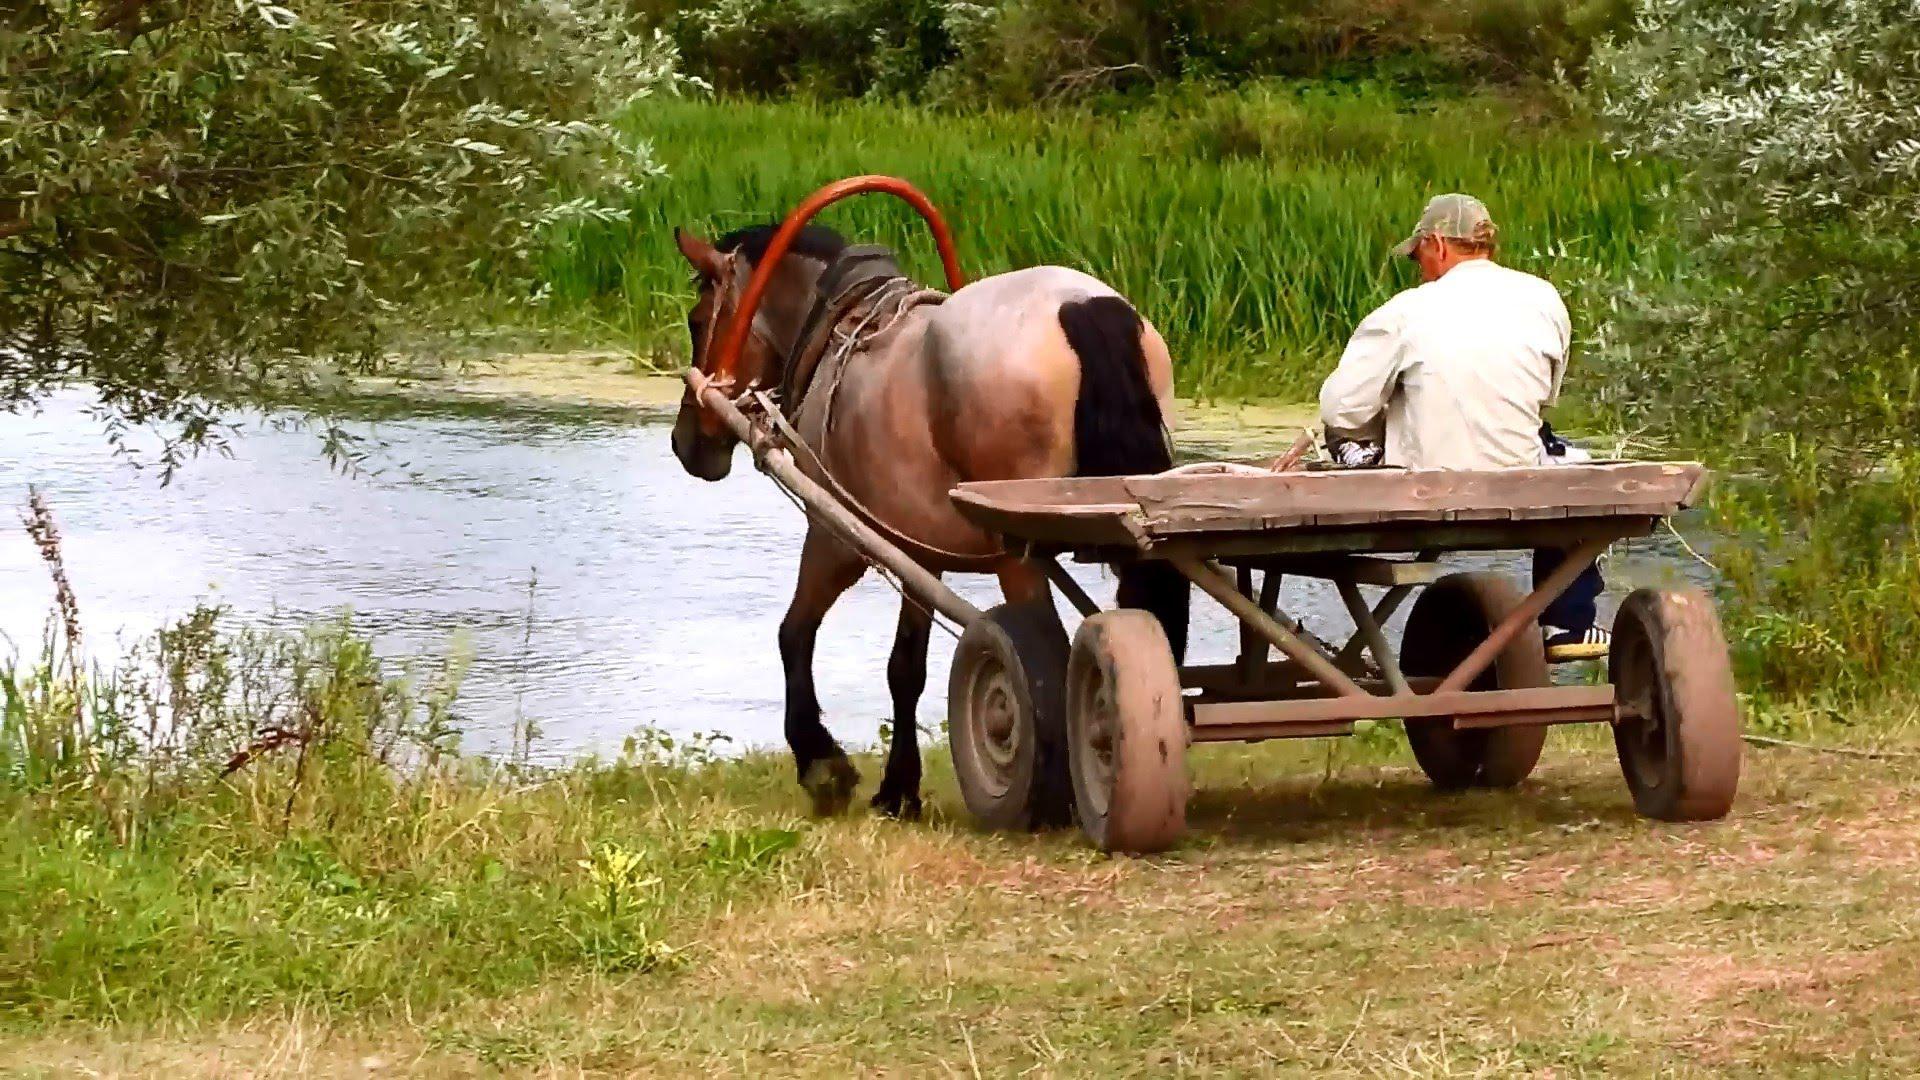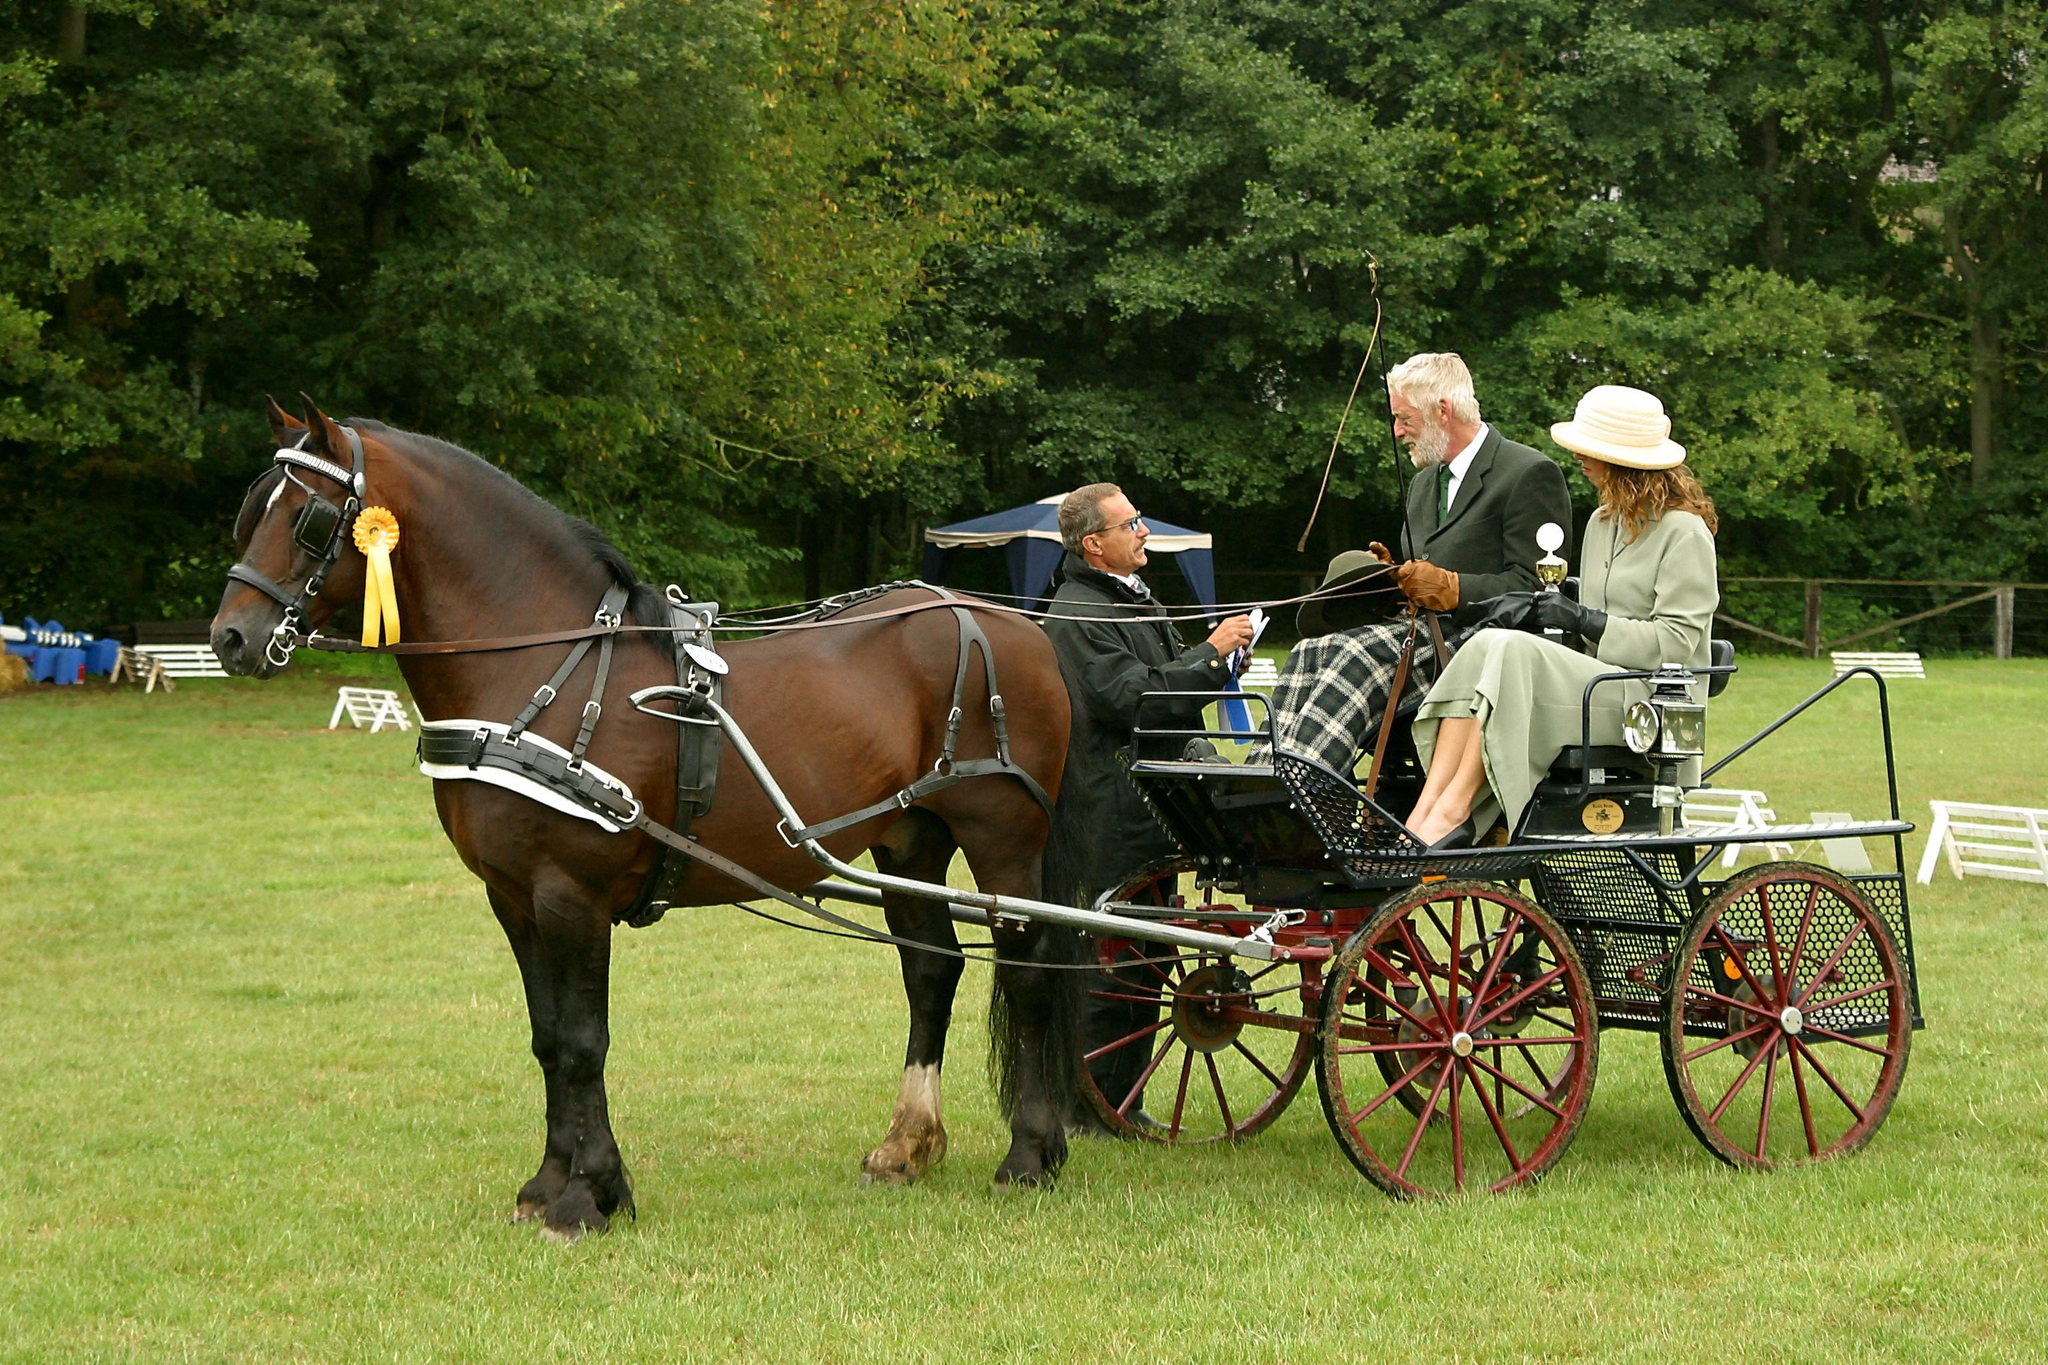The first image is the image on the left, the second image is the image on the right. Evaluate the accuracy of this statement regarding the images: "All images show one full-size horse pulling a cart.". Is it true? Answer yes or no. Yes. 